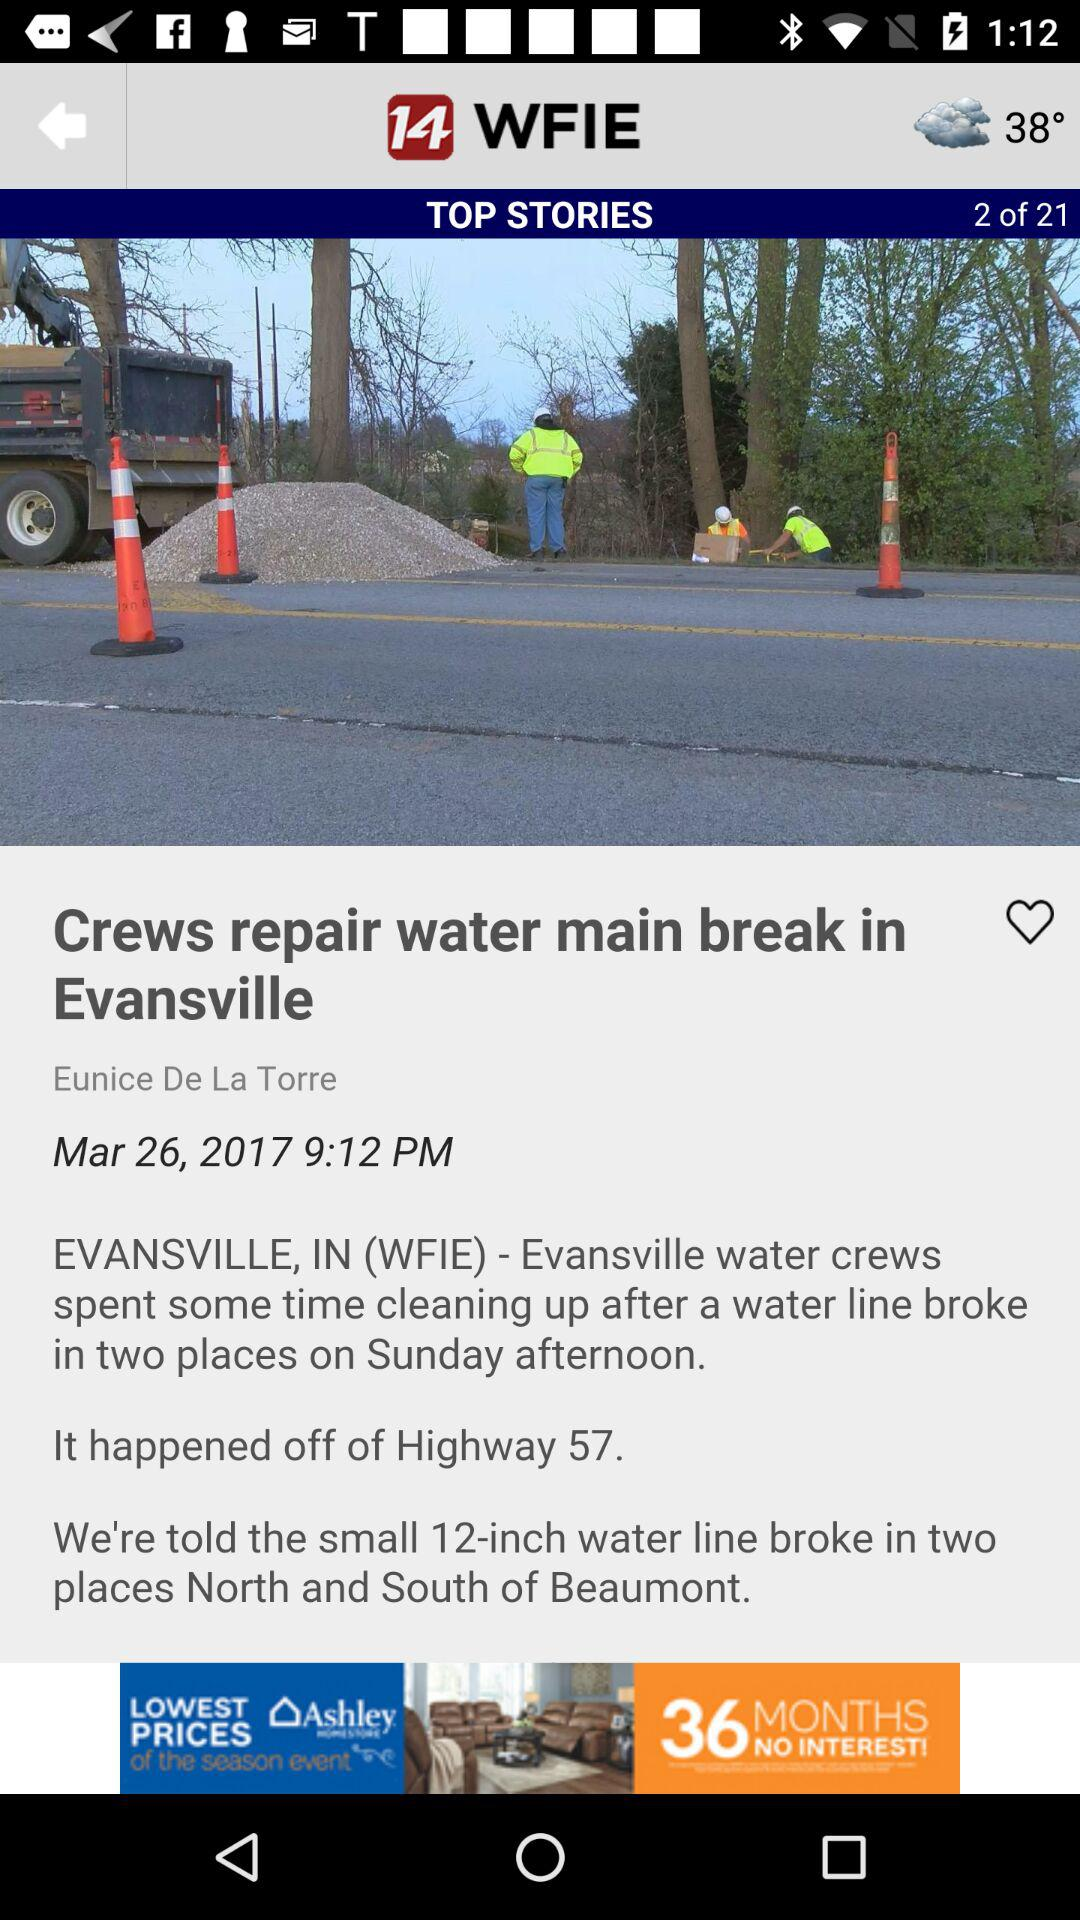At what story am I? You are at the "Crews repair water main break in Evansville" story. 